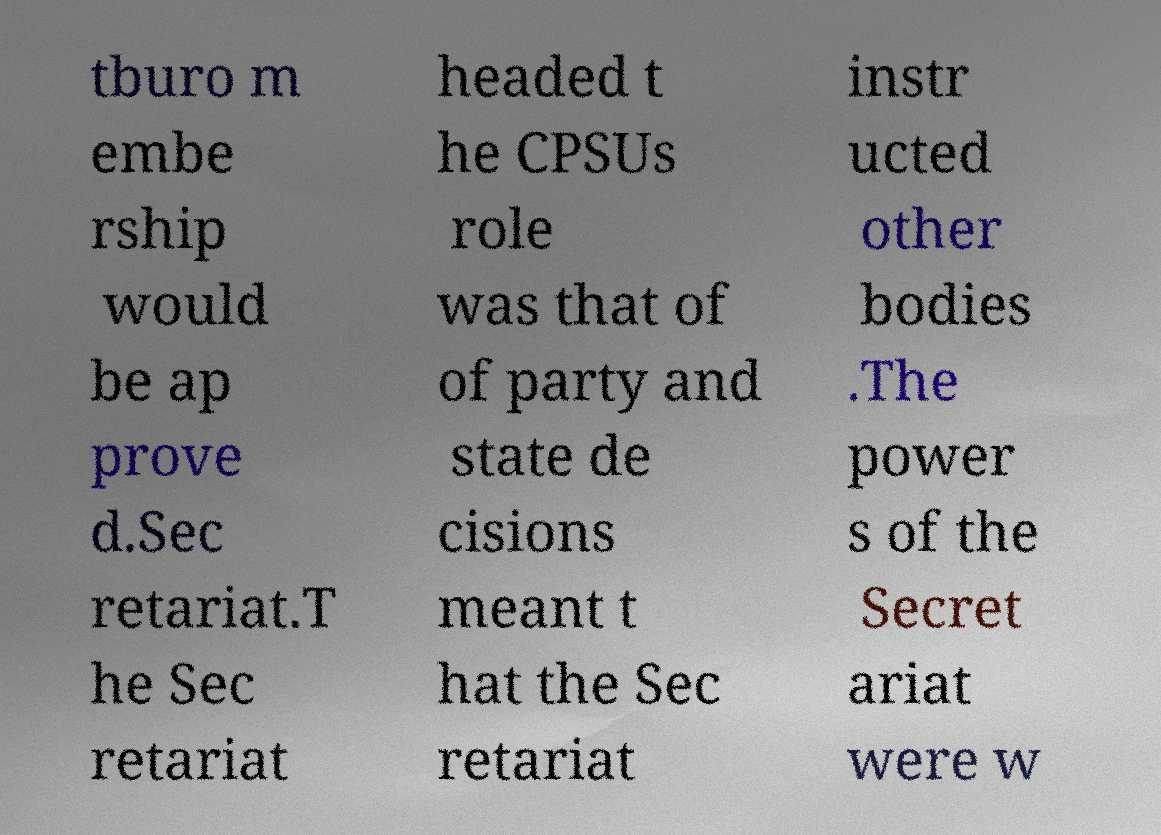Could you extract and type out the text from this image? tburo m embe rship would be ap prove d.Sec retariat.T he Sec retariat headed t he CPSUs role was that of of party and state de cisions meant t hat the Sec retariat instr ucted other bodies .The power s of the Secret ariat were w 